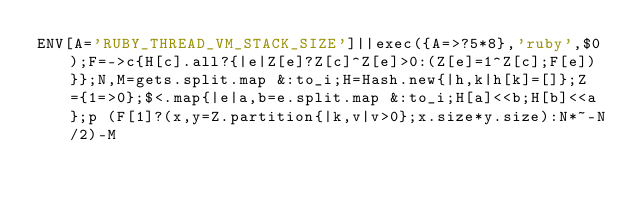Convert code to text. <code><loc_0><loc_0><loc_500><loc_500><_Ruby_>ENV[A='RUBY_THREAD_VM_STACK_SIZE']||exec({A=>?5*8},'ruby',$0);F=->c{H[c].all?{|e|Z[e]?Z[c]^Z[e]>0:(Z[e]=1^Z[c];F[e])}};N,M=gets.split.map &:to_i;H=Hash.new{|h,k|h[k]=[]};Z={1=>0};$<.map{|e|a,b=e.split.map &:to_i;H[a]<<b;H[b]<<a};p (F[1]?(x,y=Z.partition{|k,v|v>0};x.size*y.size):N*~-N/2)-M</code> 